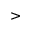<formula> <loc_0><loc_0><loc_500><loc_500>></formula> 